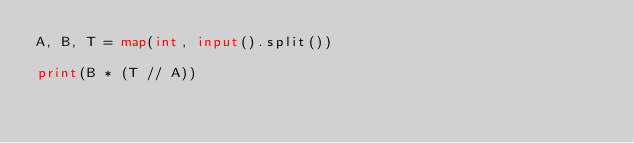Convert code to text. <code><loc_0><loc_0><loc_500><loc_500><_Python_>A, B, T = map(int, input().split())

print(B * (T // A))
</code> 